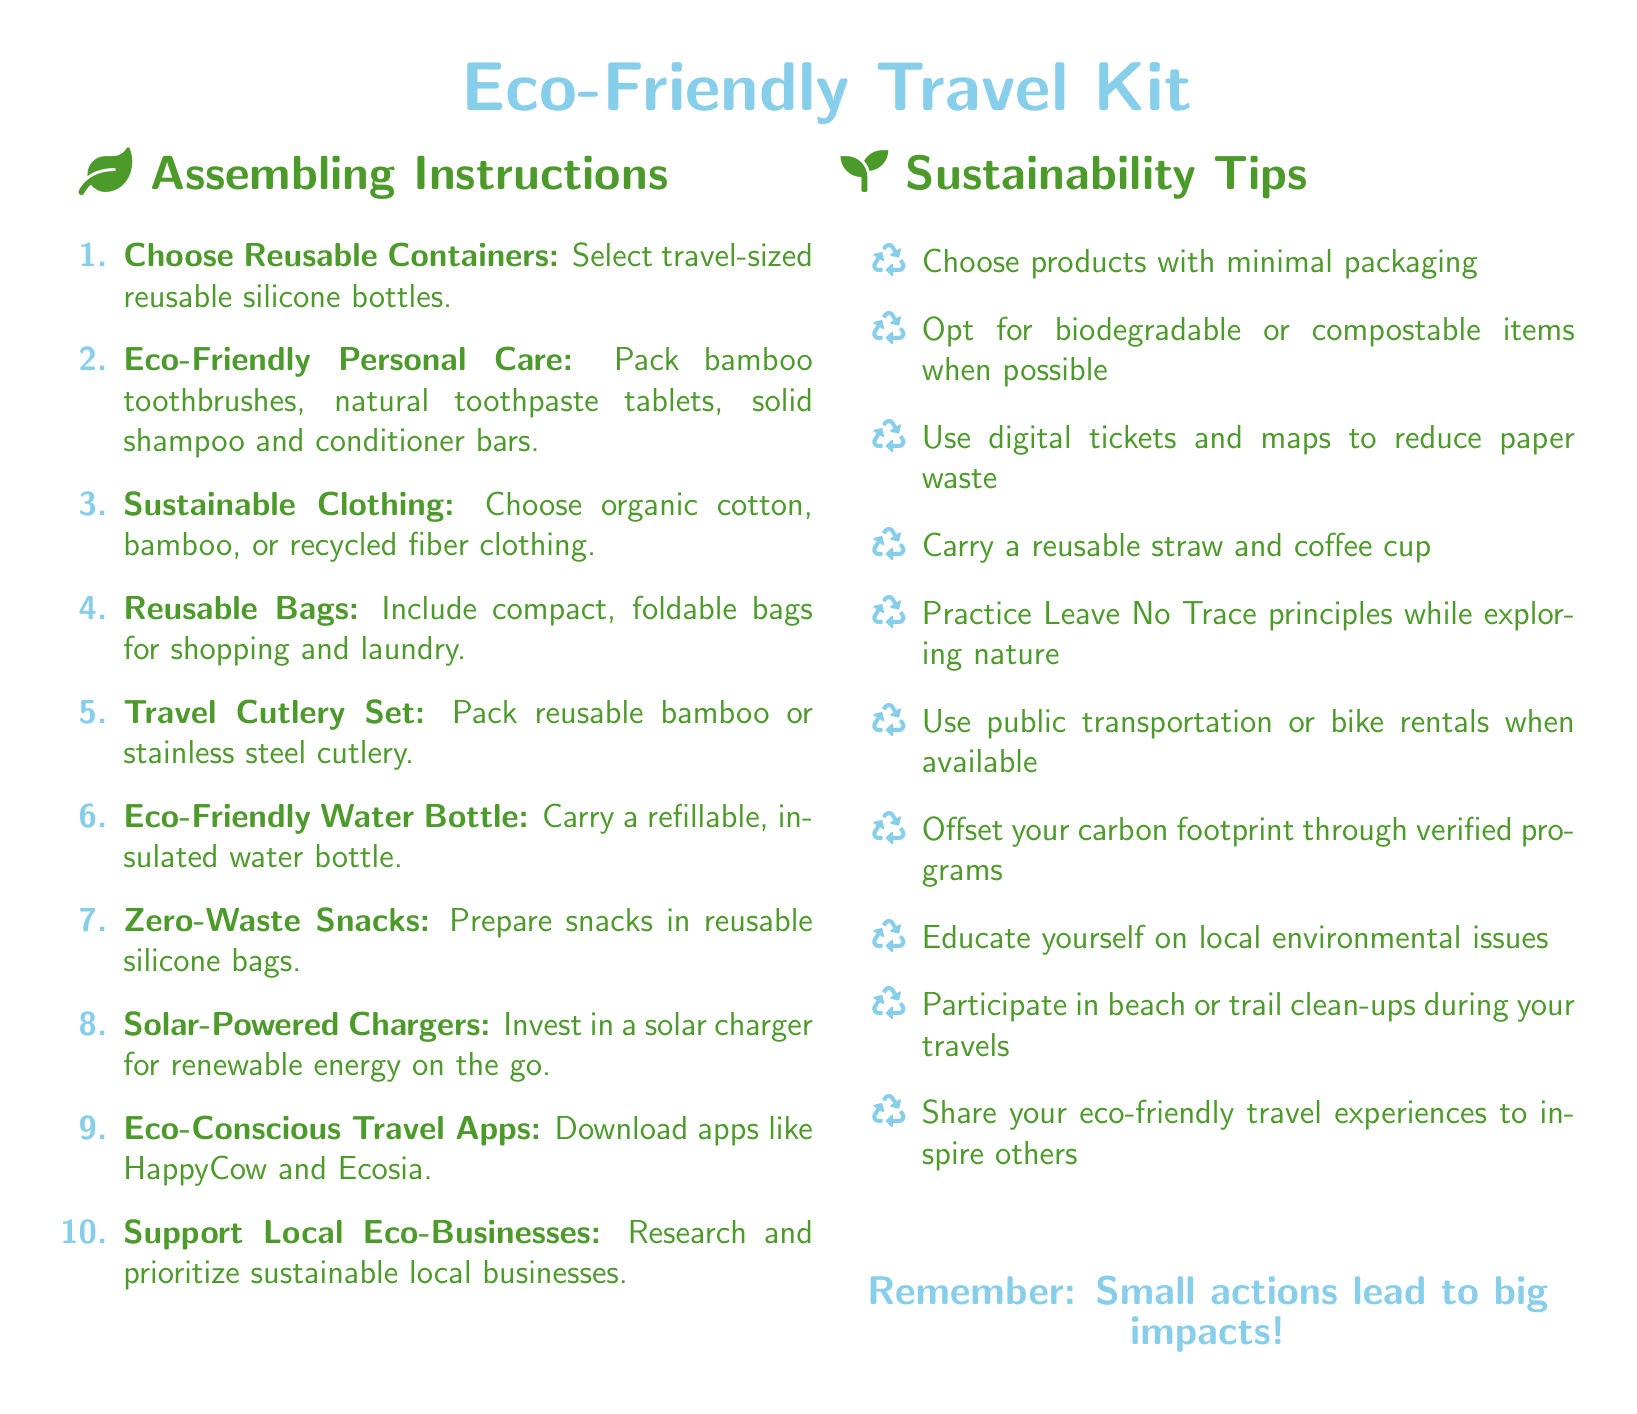what should you pack for personal care? The document suggests packing bamboo toothbrushes, natural toothpaste tablets, solid shampoo and conditioner bars for eco-friendly personal care.
Answer: bamboo toothbrushes, natural toothpaste tablets, solid shampoo and conditioner bars how many items are listed under assembling instructions? There are exactly ten items listed under the assembling instructions section of the document.
Answer: 10 what type of water bottle is recommended? The document recommends carrying a refillable, insulated water bottle as part of the eco-friendly travel kit.
Answer: refillable, insulated water bottle which type of bags should you include for shopping? The document advises including compact, foldable bags for shopping and laundry in your travel kit.
Answer: compact, foldable bags what is a recommended travel charger? The document suggests investing in a solar charger for renewable energy on the go.
Answer: solar charger what principle should you practice while exploring nature? The document states to practice Leave No Trace principles while exploring nature.
Answer: Leave No Trace principles how many sustainability tips are mentioned? The document contains ten sustainability tips listed in the sustainability section.
Answer: 10 which app is recommended for finding vegetarian options? The document recommends downloading the app HappyCow for eco-conscious travel choices.
Answer: HappyCow which materials are suggested for sustainable clothing? The document suggests choosing organic cotton, bamboo, or recycled fiber for sustainable clothing options.
Answer: organic cotton, bamboo, recycled fiber 